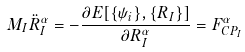Convert formula to latex. <formula><loc_0><loc_0><loc_500><loc_500>M _ { I } \ddot { R } _ { I } ^ { \alpha } = - \frac { \partial E [ \{ \psi _ { i } \} , \{ R _ { I } \} ] } { \partial R _ { I } ^ { \alpha } } = F _ { C P _ { I } } ^ { \alpha }</formula> 